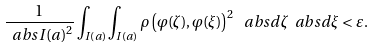Convert formula to latex. <formula><loc_0><loc_0><loc_500><loc_500>\frac { 1 } { \ a b s { I ( a ) } ^ { 2 } } \int _ { I ( a ) } \int _ { I ( a ) } \rho \left ( \varphi ( \zeta ) , \varphi ( \xi ) \right ) ^ { 2 } \, \ a b s { d \zeta } \ a b s { d \xi } < \varepsilon .</formula> 